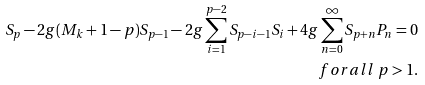Convert formula to latex. <formula><loc_0><loc_0><loc_500><loc_500>S _ { p } - 2 g ( M _ { k } + 1 - p ) S _ { p - 1 } - 2 g \sum _ { i = 1 } ^ { p - 2 } S _ { p - i - 1 } S _ { i } + 4 g \sum _ { n = 0 } ^ { \infty } S _ { p + n } P _ { n } = 0 \\ \ f o r a l l \ p > 1 .</formula> 